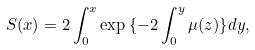Convert formula to latex. <formula><loc_0><loc_0><loc_500><loc_500>S ( x ) = 2 \int ^ { x } _ { 0 } \exp { \{ - 2 \int ^ { y } _ { 0 } \mu ( z ) \} } d y ,</formula> 